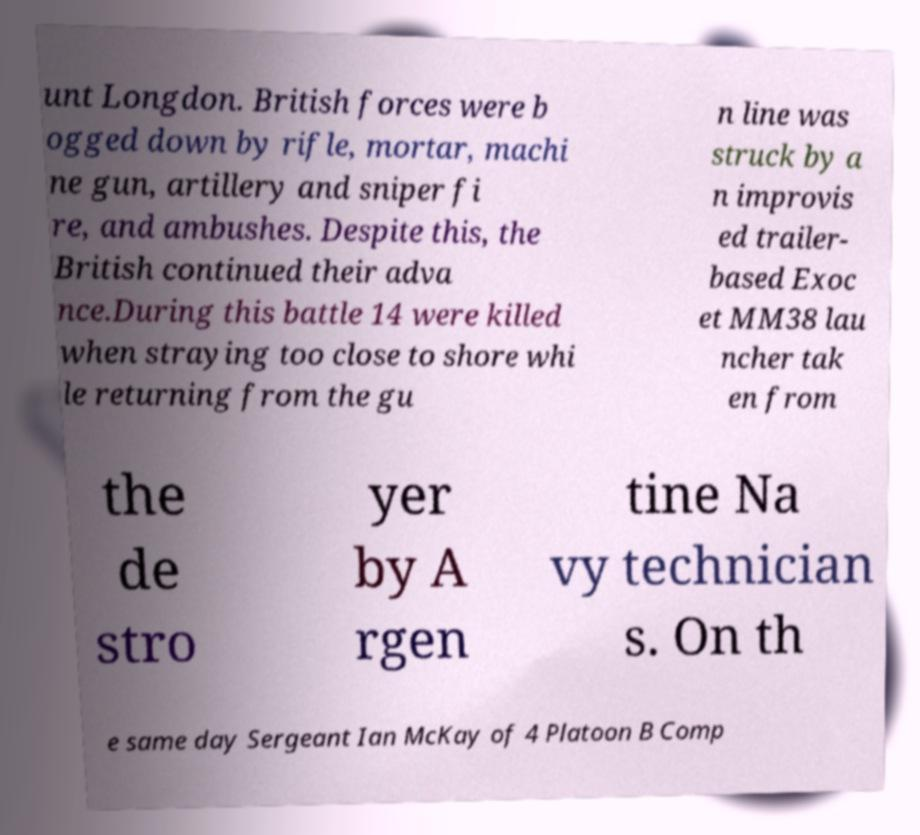Please identify and transcribe the text found in this image. unt Longdon. British forces were b ogged down by rifle, mortar, machi ne gun, artillery and sniper fi re, and ambushes. Despite this, the British continued their adva nce.During this battle 14 were killed when straying too close to shore whi le returning from the gu n line was struck by a n improvis ed trailer- based Exoc et MM38 lau ncher tak en from the de stro yer by A rgen tine Na vy technician s. On th e same day Sergeant Ian McKay of 4 Platoon B Comp 